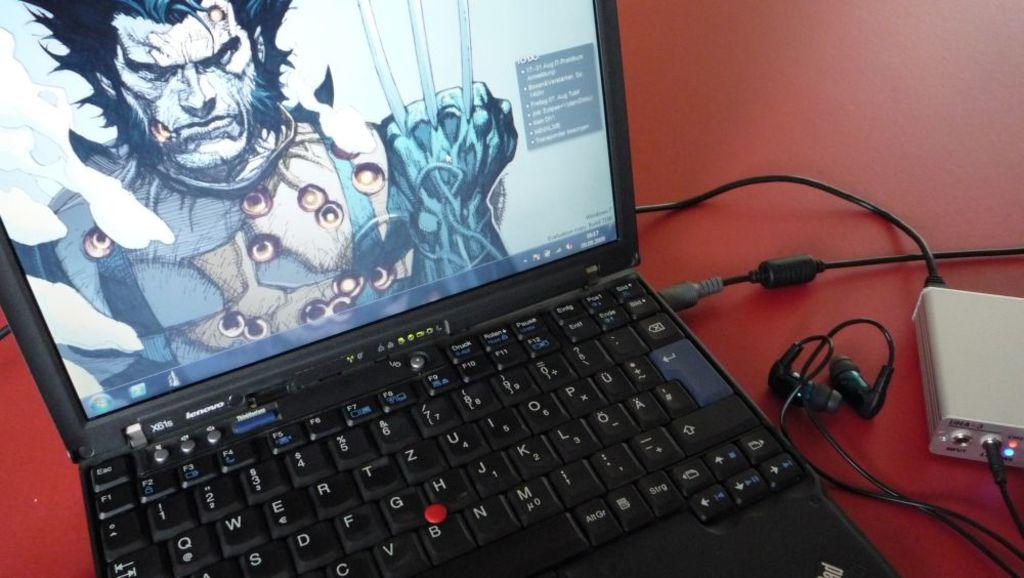What electronic device is visible in the image? There is a laptop in the image. What is displayed on the laptop's screen? The laptop has an image and text on its screen. Are there any accessories connected to the laptop? Yes, there are wires visible in the image. What type of audio device is present in the image? Headphones are present in the image. Can you describe the object on the right side of the image? Unfortunately, the provided facts do not give enough information to describe the object on the right side of the image. What is the color of the surface in the image? The surface in the image is red in color. What type of silverware is visible in the image? There is no silverware present in the image. How does the harbor contribute to the image? There is no harbor present in the image. 